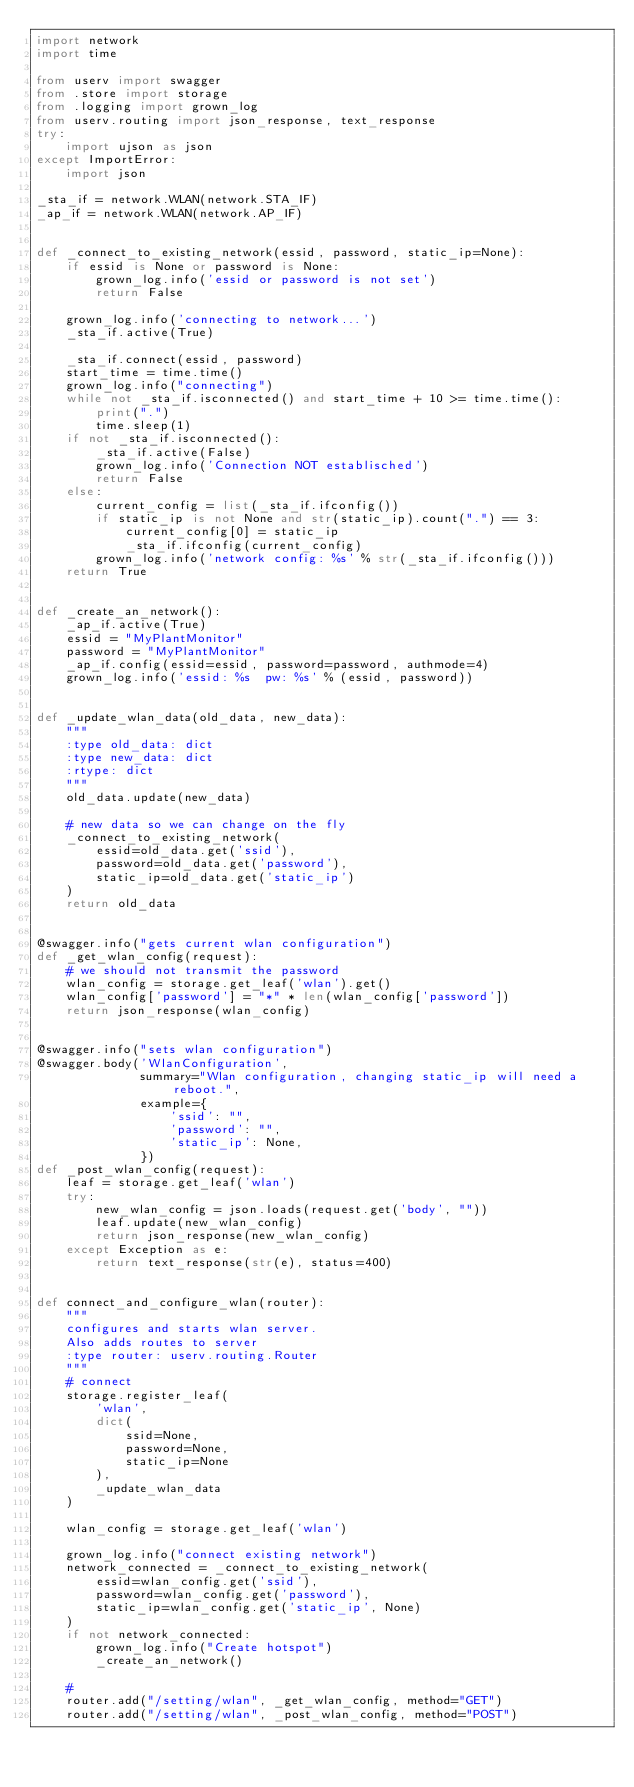<code> <loc_0><loc_0><loc_500><loc_500><_Python_>import network
import time

from userv import swagger
from .store import storage
from .logging import grown_log
from userv.routing import json_response, text_response
try:
    import ujson as json
except ImportError:
    import json

_sta_if = network.WLAN(network.STA_IF)
_ap_if = network.WLAN(network.AP_IF)


def _connect_to_existing_network(essid, password, static_ip=None):
    if essid is None or password is None:
        grown_log.info('essid or password is not set')
        return False

    grown_log.info('connecting to network...')
    _sta_if.active(True)

    _sta_if.connect(essid, password)
    start_time = time.time()
    grown_log.info("connecting")
    while not _sta_if.isconnected() and start_time + 10 >= time.time():
        print(".")
        time.sleep(1)
    if not _sta_if.isconnected():
        _sta_if.active(False)
        grown_log.info('Connection NOT establisched')
        return False
    else:
        current_config = list(_sta_if.ifconfig())
        if static_ip is not None and str(static_ip).count(".") == 3:
            current_config[0] = static_ip
            _sta_if.ifconfig(current_config)
        grown_log.info('network config: %s' % str(_sta_if.ifconfig()))
    return True


def _create_an_network():
    _ap_if.active(True)
    essid = "MyPlantMonitor"
    password = "MyPlantMonitor"
    _ap_if.config(essid=essid, password=password, authmode=4)
    grown_log.info('essid: %s  pw: %s' % (essid, password))


def _update_wlan_data(old_data, new_data):
    """
    :type old_data: dict
    :type new_data: dict
    :rtype: dict
    """
    old_data.update(new_data)

    # new data so we can change on the fly
    _connect_to_existing_network(
        essid=old_data.get('ssid'),
        password=old_data.get('password'),
        static_ip=old_data.get('static_ip')
    )
    return old_data


@swagger.info("gets current wlan configuration")
def _get_wlan_config(request):
    # we should not transmit the password
    wlan_config = storage.get_leaf('wlan').get()
    wlan_config['password'] = "*" * len(wlan_config['password'])
    return json_response(wlan_config)


@swagger.info("sets wlan configuration")
@swagger.body('WlanConfiguration',
              summary="Wlan configuration, changing static_ip will need a reboot.",
              example={
                  'ssid': "",
                  'password': "",
                  'static_ip': None,
              })
def _post_wlan_config(request):
    leaf = storage.get_leaf('wlan')
    try:
        new_wlan_config = json.loads(request.get('body', ""))
        leaf.update(new_wlan_config)
        return json_response(new_wlan_config)
    except Exception as e:
        return text_response(str(e), status=400)


def connect_and_configure_wlan(router):
    """
    configures and starts wlan server.
    Also adds routes to server
    :type router: userv.routing.Router
    """
    # connect
    storage.register_leaf(
        'wlan',
        dict(
            ssid=None,
            password=None,
            static_ip=None
        ),
        _update_wlan_data
    )

    wlan_config = storage.get_leaf('wlan')

    grown_log.info("connect existing network")
    network_connected = _connect_to_existing_network(
        essid=wlan_config.get('ssid'),
        password=wlan_config.get('password'),
        static_ip=wlan_config.get('static_ip', None)
    )
    if not network_connected:
        grown_log.info("Create hotspot")
        _create_an_network()

    #
    router.add("/setting/wlan", _get_wlan_config, method="GET")
    router.add("/setting/wlan", _post_wlan_config, method="POST")
</code> 